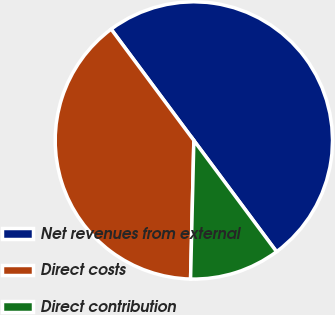Convert chart. <chart><loc_0><loc_0><loc_500><loc_500><pie_chart><fcel>Net revenues from external<fcel>Direct costs<fcel>Direct contribution<nl><fcel>50.0%<fcel>39.45%<fcel>10.55%<nl></chart> 